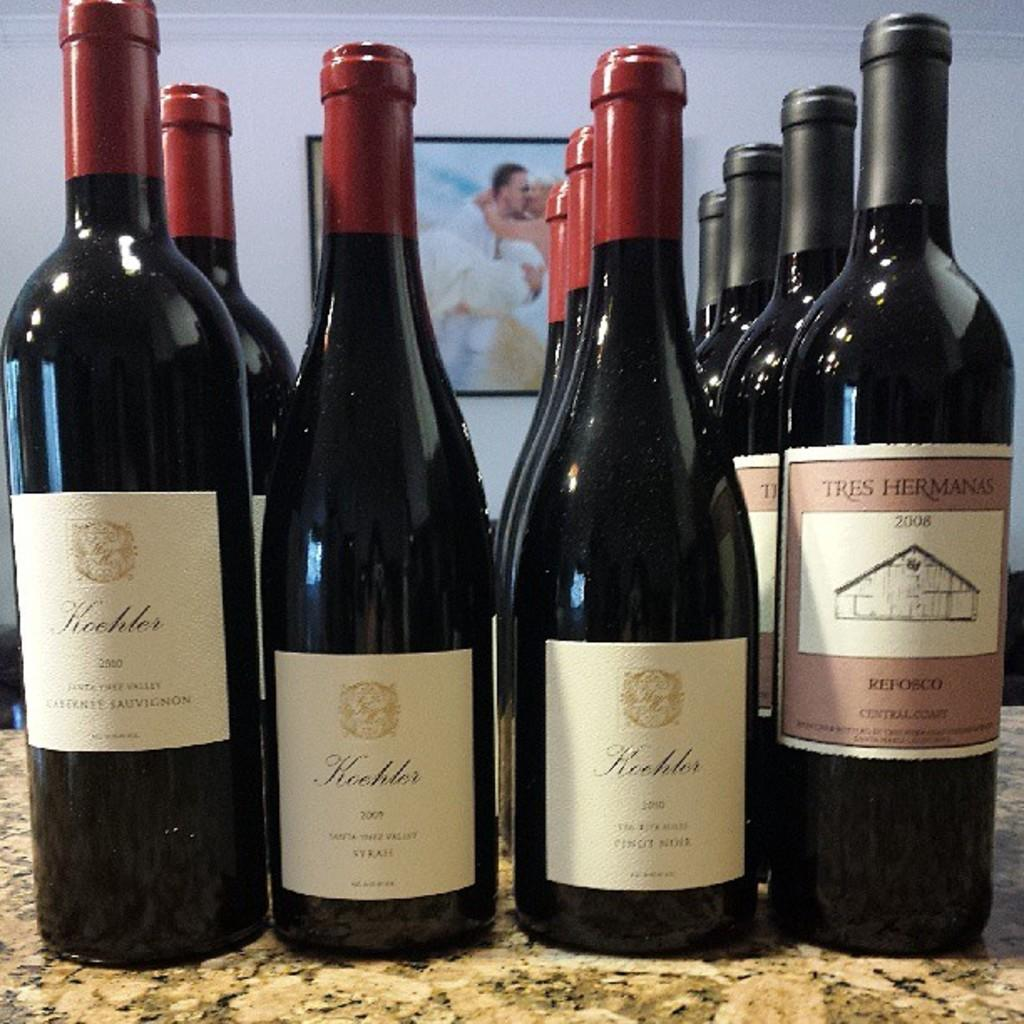<image>
Give a short and clear explanation of the subsequent image. A bottle of Tisdale wine with a chicken cork in it. 